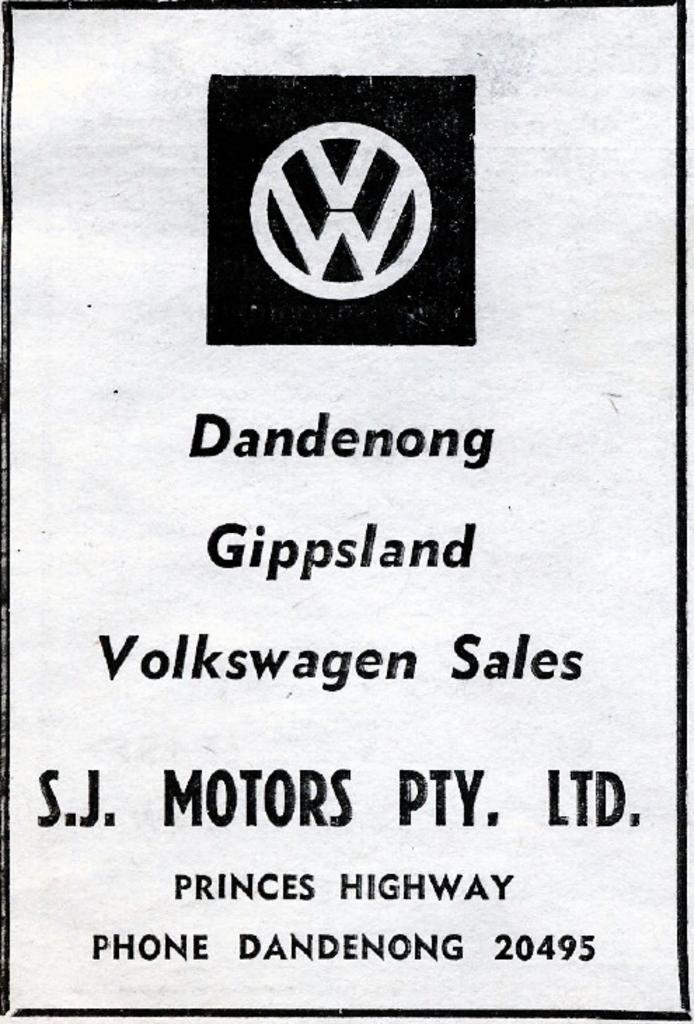<image>
Give a short and clear explanation of the subsequent image. A Volkswagon ad for features the VW logo for a store in Dandenong 